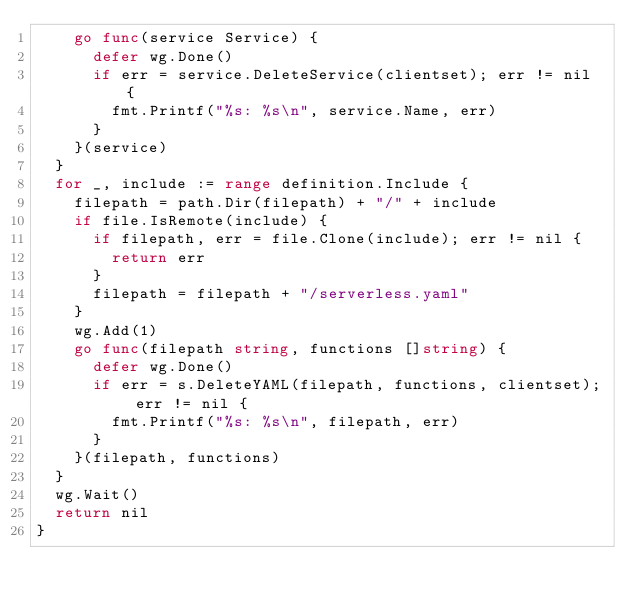Convert code to text. <code><loc_0><loc_0><loc_500><loc_500><_Go_>		go func(service Service) {
			defer wg.Done()
			if err = service.DeleteService(clientset); err != nil {
				fmt.Printf("%s: %s\n", service.Name, err)
			}
		}(service)
	}
	for _, include := range definition.Include {
		filepath = path.Dir(filepath) + "/" + include
		if file.IsRemote(include) {
			if filepath, err = file.Clone(include); err != nil {
				return err
			}
			filepath = filepath + "/serverless.yaml"
		}
		wg.Add(1)
		go func(filepath string, functions []string) {
			defer wg.Done()
			if err = s.DeleteYAML(filepath, functions, clientset); err != nil {
				fmt.Printf("%s: %s\n", filepath, err)
			}
		}(filepath, functions)
	}
	wg.Wait()
	return nil
}
</code> 